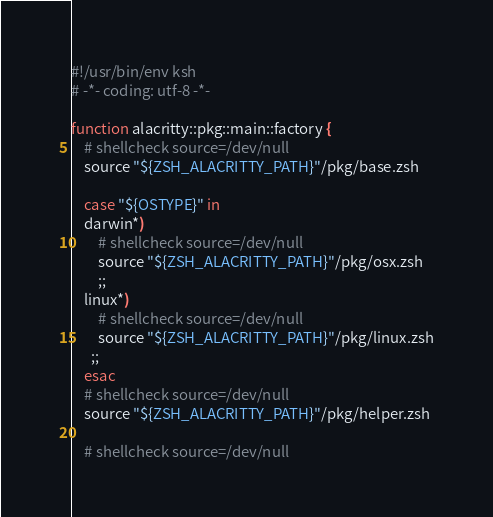<code> <loc_0><loc_0><loc_500><loc_500><_Bash_>#!/usr/bin/env ksh
# -*- coding: utf-8 -*-

function alacritty::pkg::main::factory {
    # shellcheck source=/dev/null
    source "${ZSH_ALACRITTY_PATH}"/pkg/base.zsh

    case "${OSTYPE}" in
    darwin*)
        # shellcheck source=/dev/null
        source "${ZSH_ALACRITTY_PATH}"/pkg/osx.zsh
        ;;
    linux*)
        # shellcheck source=/dev/null
        source "${ZSH_ALACRITTY_PATH}"/pkg/linux.zsh
      ;;
    esac
    # shellcheck source=/dev/null
    source "${ZSH_ALACRITTY_PATH}"/pkg/helper.zsh

    # shellcheck source=/dev/null</code> 